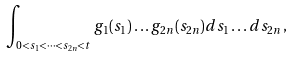Convert formula to latex. <formula><loc_0><loc_0><loc_500><loc_500>\int _ { 0 < s _ { 1 } < \dots < s _ { 2 n } < t } g _ { 1 } ( s _ { 1 } ) \dots g _ { 2 n } ( s _ { 2 n } ) d s _ { 1 } \dots d s _ { 2 n } \, ,</formula> 